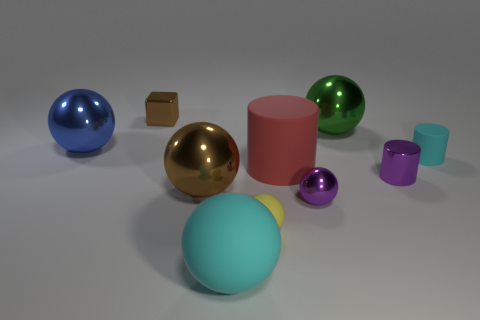There is a matte object that is the same color as the big matte sphere; what is its shape?
Provide a succinct answer. Cylinder. How big is the ball that is to the right of the yellow thing and in front of the blue ball?
Provide a short and direct response. Small. Does the small thing on the left side of the big rubber sphere have the same color as the big metal object in front of the tiny matte cylinder?
Your answer should be very brief. Yes. What number of other objects are there of the same shape as the small brown metallic object?
Offer a very short reply. 0. Are there more rubber objects that are on the right side of the large matte cylinder than small red rubber cubes?
Offer a very short reply. Yes. There is a small shiny object on the left side of the big cyan rubber object; what is its color?
Your answer should be compact. Brown. What size is the shiny sphere that is the same color as the tiny metal cube?
Offer a terse response. Large. What number of shiny objects are large cubes or large red objects?
Give a very brief answer. 0. There is a brown shiny object on the right side of the brown object that is behind the red cylinder; is there a object that is on the left side of it?
Ensure brevity in your answer.  Yes. There is a brown block; how many small purple shiny spheres are right of it?
Keep it short and to the point. 1. 